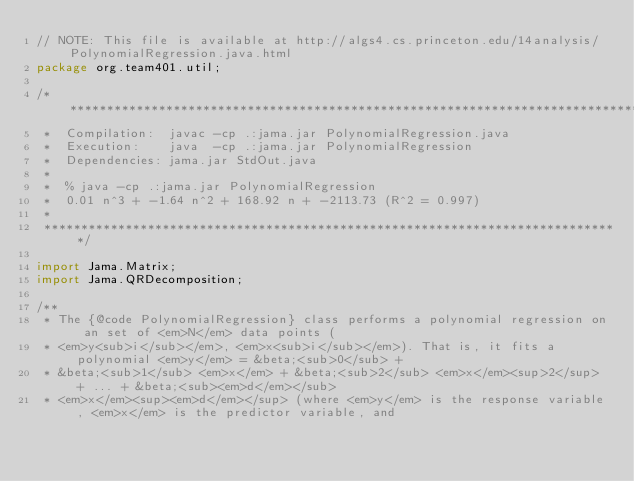Convert code to text. <code><loc_0><loc_0><loc_500><loc_500><_Java_>// NOTE: This file is available at http://algs4.cs.princeton.edu/14analysis/PolynomialRegression.java.html
package org.team401.util;

/******************************************************************************
 *  Compilation:  javac -cp .:jama.jar PolynomialRegression.java
 *  Execution:    java  -cp .:jama.jar PolynomialRegression
 *  Dependencies: jama.jar StdOut.java
 *
 *  % java -cp .:jama.jar PolynomialRegression
 *  0.01 n^3 + -1.64 n^2 + 168.92 n + -2113.73 (R^2 = 0.997)
 *
 ******************************************************************************/

import Jama.Matrix;
import Jama.QRDecomposition;

/**
 * The {@code PolynomialRegression} class performs a polynomial regression on an set of <em>N</em> data points (
 * <em>y<sub>i</sub></em>, <em>x<sub>i</sub></em>). That is, it fits a polynomial <em>y</em> = &beta;<sub>0</sub> +
 * &beta;<sub>1</sub> <em>x</em> + &beta;<sub>2</sub> <em>x</em><sup>2</sup> + ... + &beta;<sub><em>d</em></sub>
 * <em>x</em><sup><em>d</em></sup> (where <em>y</em> is the response variable, <em>x</em> is the predictor variable, and</code> 